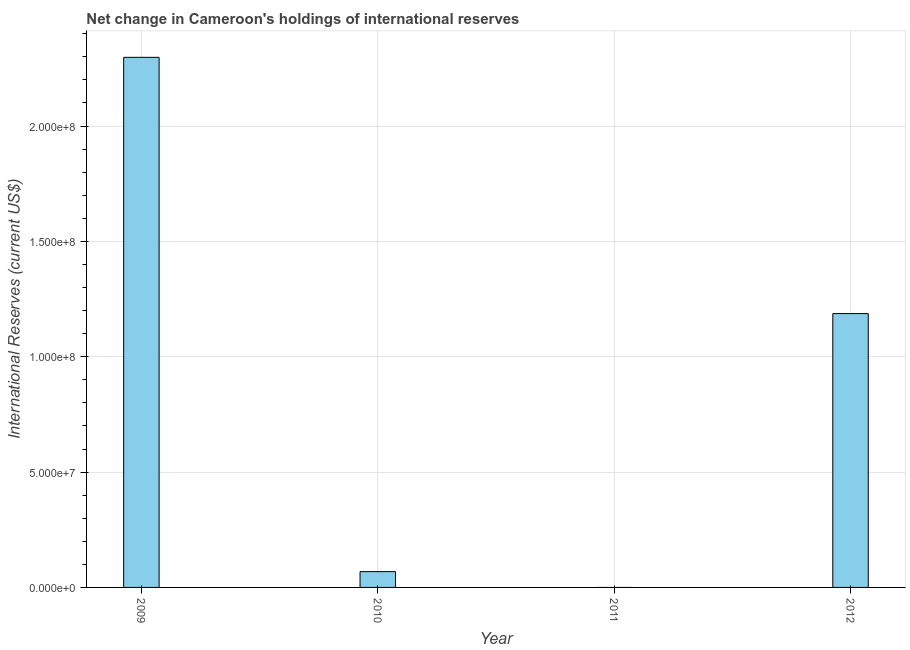Does the graph contain any zero values?
Ensure brevity in your answer.  Yes. Does the graph contain grids?
Keep it short and to the point. Yes. What is the title of the graph?
Give a very brief answer. Net change in Cameroon's holdings of international reserves. What is the label or title of the Y-axis?
Make the answer very short. International Reserves (current US$). What is the reserves and related items in 2009?
Your answer should be compact. 2.30e+08. Across all years, what is the maximum reserves and related items?
Your answer should be compact. 2.30e+08. Across all years, what is the minimum reserves and related items?
Make the answer very short. 0. What is the sum of the reserves and related items?
Keep it short and to the point. 3.55e+08. What is the difference between the reserves and related items in 2009 and 2010?
Provide a short and direct response. 2.23e+08. What is the average reserves and related items per year?
Provide a succinct answer. 8.88e+07. What is the median reserves and related items?
Offer a very short reply. 6.28e+07. Is the reserves and related items in 2009 less than that in 2012?
Make the answer very short. No. What is the difference between the highest and the second highest reserves and related items?
Provide a succinct answer. 1.11e+08. What is the difference between the highest and the lowest reserves and related items?
Provide a short and direct response. 2.30e+08. How many years are there in the graph?
Your answer should be compact. 4. Are the values on the major ticks of Y-axis written in scientific E-notation?
Make the answer very short. Yes. What is the International Reserves (current US$) in 2009?
Your answer should be very brief. 2.30e+08. What is the International Reserves (current US$) of 2010?
Your answer should be compact. 6.84e+06. What is the International Reserves (current US$) in 2011?
Keep it short and to the point. 0. What is the International Reserves (current US$) of 2012?
Provide a short and direct response. 1.19e+08. What is the difference between the International Reserves (current US$) in 2009 and 2010?
Ensure brevity in your answer.  2.23e+08. What is the difference between the International Reserves (current US$) in 2009 and 2012?
Offer a terse response. 1.11e+08. What is the difference between the International Reserves (current US$) in 2010 and 2012?
Provide a succinct answer. -1.12e+08. What is the ratio of the International Reserves (current US$) in 2009 to that in 2010?
Offer a terse response. 33.57. What is the ratio of the International Reserves (current US$) in 2009 to that in 2012?
Ensure brevity in your answer.  1.94. What is the ratio of the International Reserves (current US$) in 2010 to that in 2012?
Your answer should be compact. 0.06. 